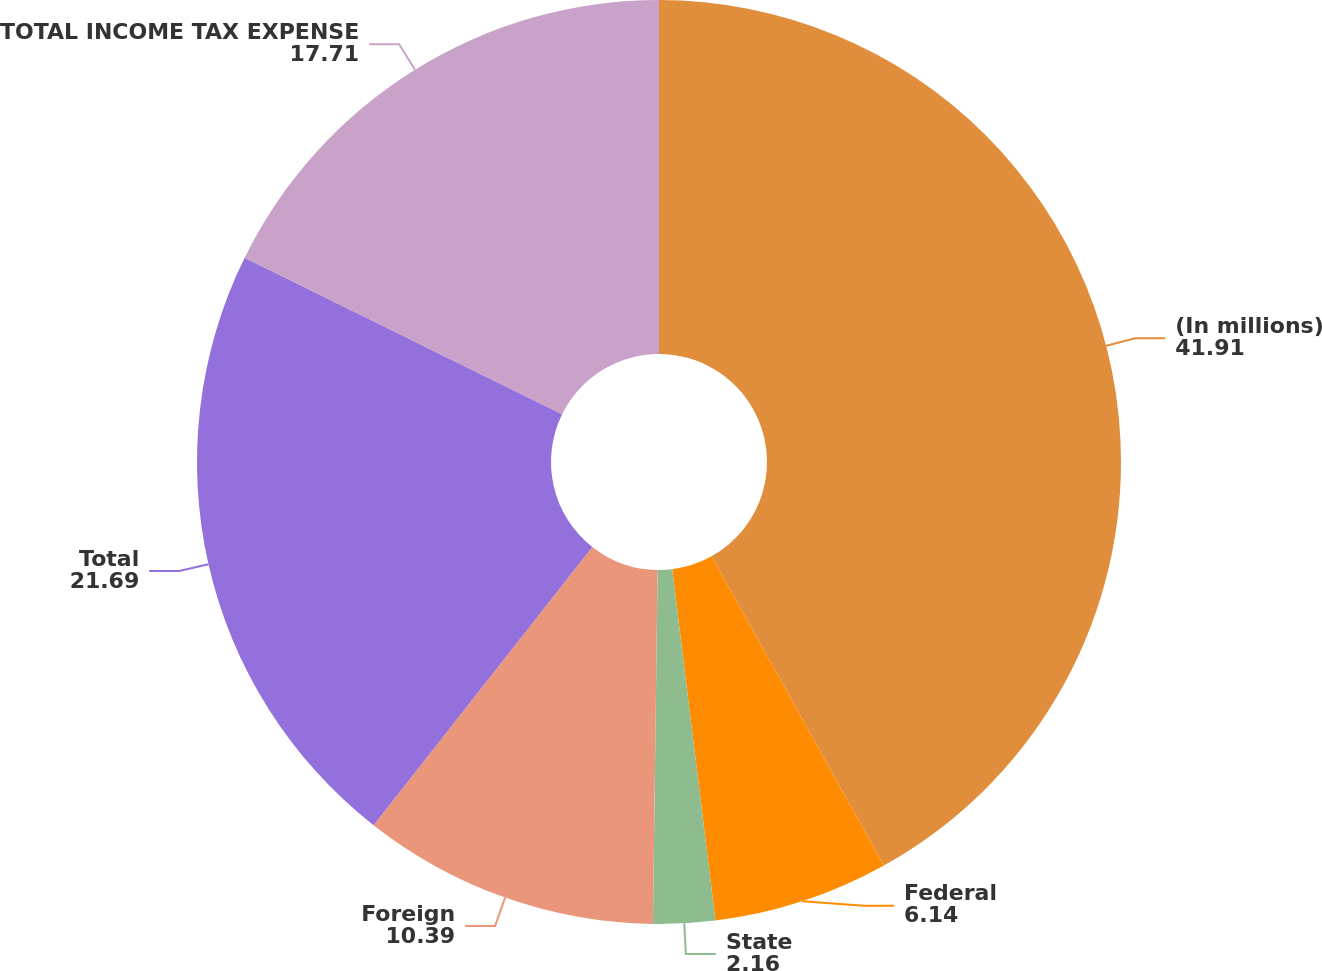Convert chart to OTSL. <chart><loc_0><loc_0><loc_500><loc_500><pie_chart><fcel>(In millions)<fcel>Federal<fcel>State<fcel>Foreign<fcel>Total<fcel>TOTAL INCOME TAX EXPENSE<nl><fcel>41.91%<fcel>6.14%<fcel>2.16%<fcel>10.39%<fcel>21.69%<fcel>17.71%<nl></chart> 